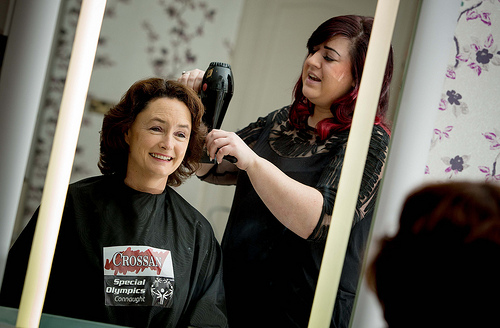<image>
Is the woman behind the woman? Yes. From this viewpoint, the woman is positioned behind the woman, with the woman partially or fully occluding the woman. 